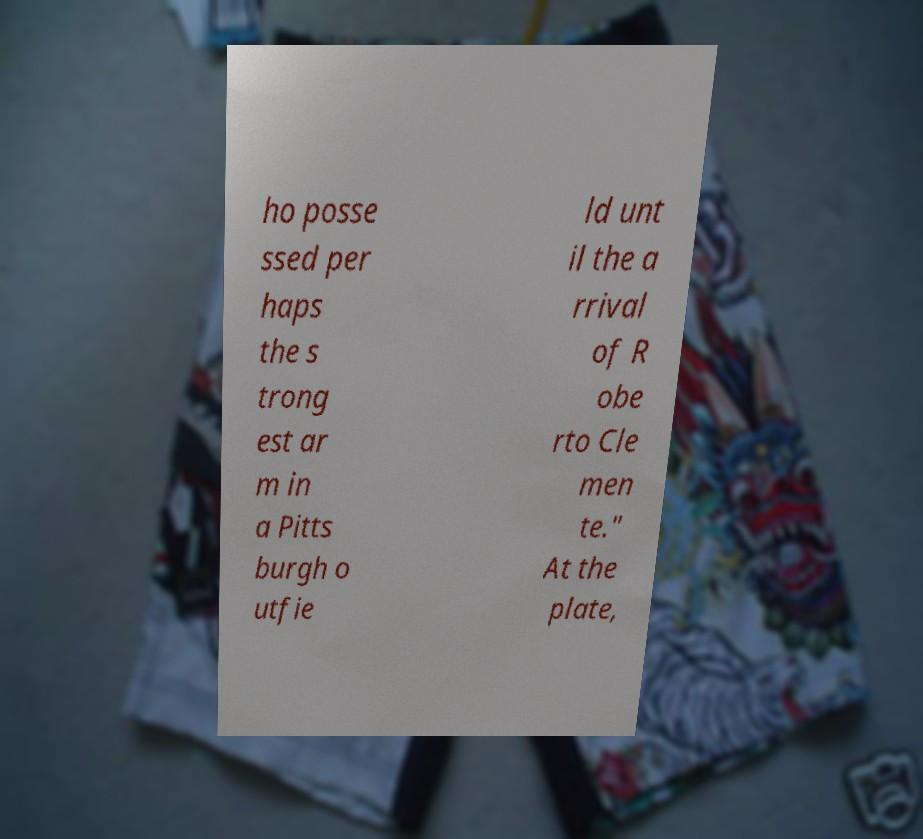I need the written content from this picture converted into text. Can you do that? ho posse ssed per haps the s trong est ar m in a Pitts burgh o utfie ld unt il the a rrival of R obe rto Cle men te." At the plate, 